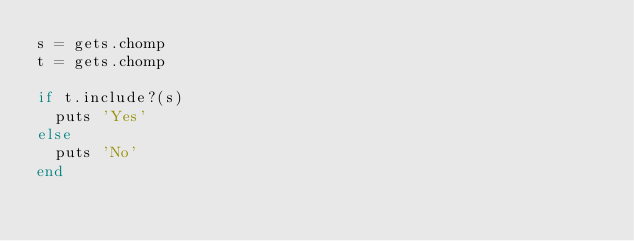<code> <loc_0><loc_0><loc_500><loc_500><_Ruby_>s = gets.chomp
t = gets.chomp

if t.include?(s)
  puts 'Yes'
else
  puts 'No'
end</code> 